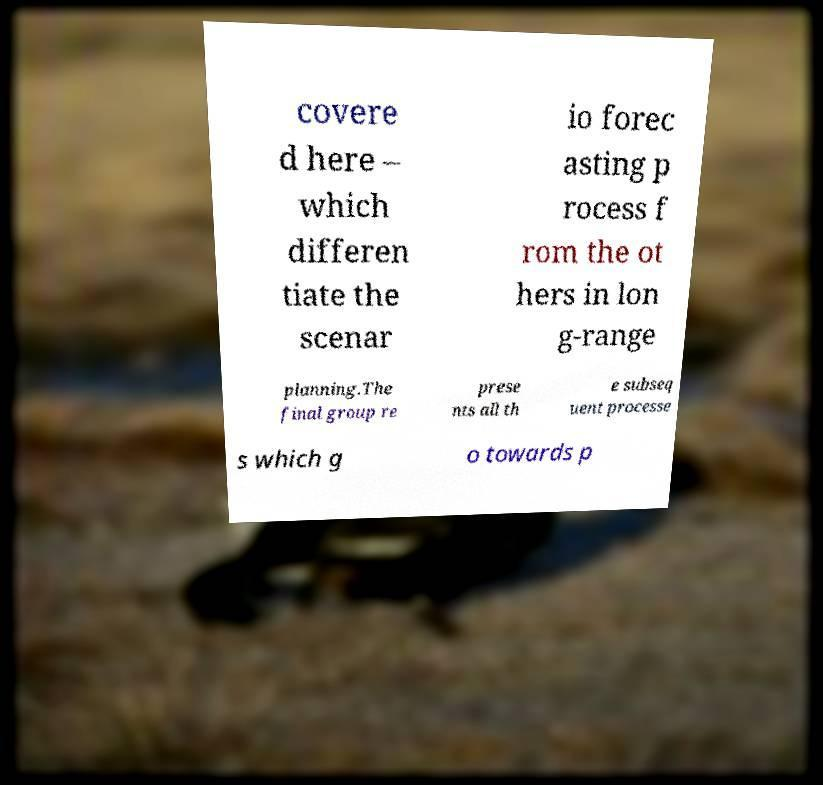Please read and relay the text visible in this image. What does it say? covere d here – which differen tiate the scenar io forec asting p rocess f rom the ot hers in lon g-range planning.The final group re prese nts all th e subseq uent processe s which g o towards p 